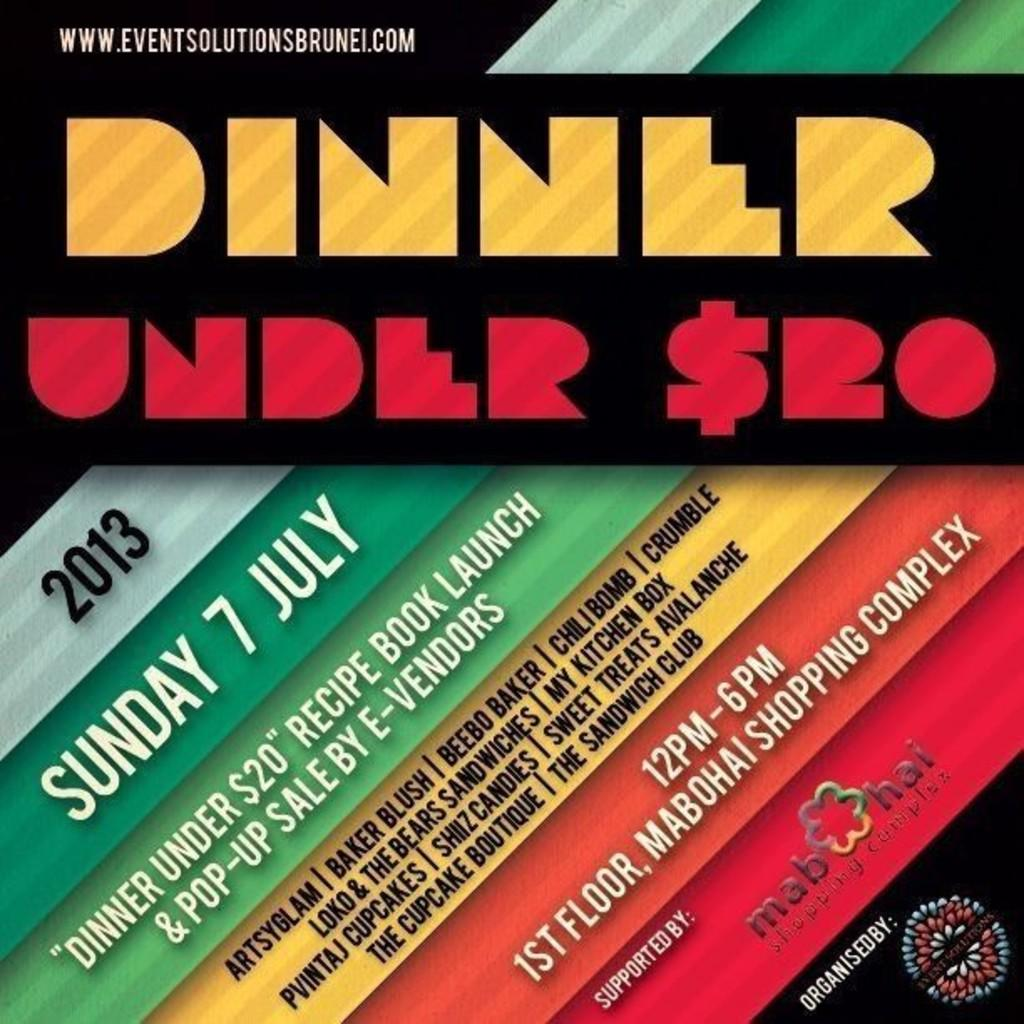<image>
Relay a brief, clear account of the picture shown. An ad in black, red, and yellow advertises dinner under twenty dollars. 